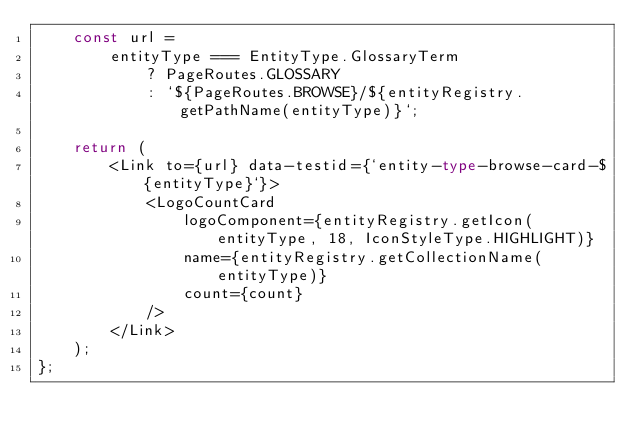<code> <loc_0><loc_0><loc_500><loc_500><_TypeScript_>    const url =
        entityType === EntityType.GlossaryTerm
            ? PageRoutes.GLOSSARY
            : `${PageRoutes.BROWSE}/${entityRegistry.getPathName(entityType)}`;

    return (
        <Link to={url} data-testid={`entity-type-browse-card-${entityType}`}>
            <LogoCountCard
                logoComponent={entityRegistry.getIcon(entityType, 18, IconStyleType.HIGHLIGHT)}
                name={entityRegistry.getCollectionName(entityType)}
                count={count}
            />
        </Link>
    );
};
</code> 